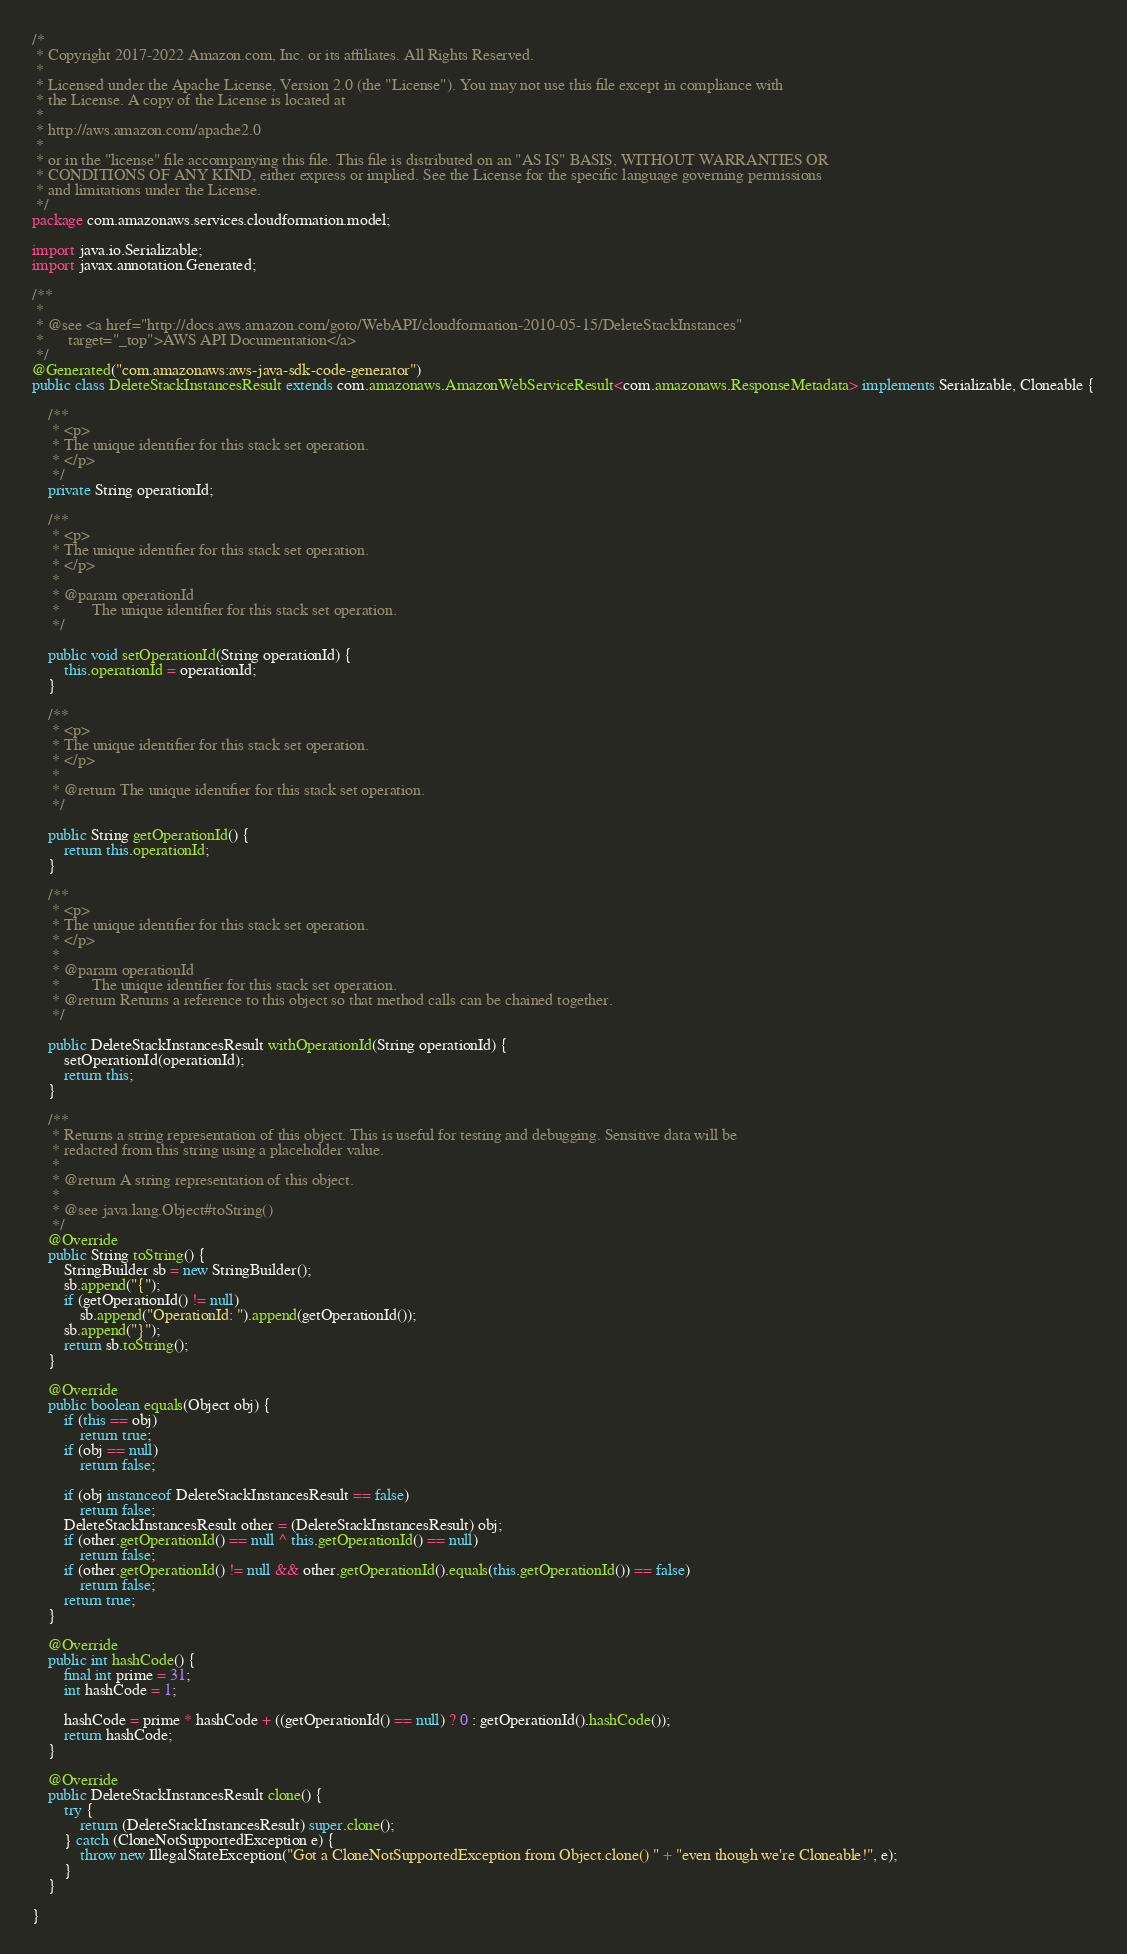<code> <loc_0><loc_0><loc_500><loc_500><_Java_>/*
 * Copyright 2017-2022 Amazon.com, Inc. or its affiliates. All Rights Reserved.
 * 
 * Licensed under the Apache License, Version 2.0 (the "License"). You may not use this file except in compliance with
 * the License. A copy of the License is located at
 * 
 * http://aws.amazon.com/apache2.0
 * 
 * or in the "license" file accompanying this file. This file is distributed on an "AS IS" BASIS, WITHOUT WARRANTIES OR
 * CONDITIONS OF ANY KIND, either express or implied. See the License for the specific language governing permissions
 * and limitations under the License.
 */
package com.amazonaws.services.cloudformation.model;

import java.io.Serializable;
import javax.annotation.Generated;

/**
 * 
 * @see <a href="http://docs.aws.amazon.com/goto/WebAPI/cloudformation-2010-05-15/DeleteStackInstances"
 *      target="_top">AWS API Documentation</a>
 */
@Generated("com.amazonaws:aws-java-sdk-code-generator")
public class DeleteStackInstancesResult extends com.amazonaws.AmazonWebServiceResult<com.amazonaws.ResponseMetadata> implements Serializable, Cloneable {

    /**
     * <p>
     * The unique identifier for this stack set operation.
     * </p>
     */
    private String operationId;

    /**
     * <p>
     * The unique identifier for this stack set operation.
     * </p>
     * 
     * @param operationId
     *        The unique identifier for this stack set operation.
     */

    public void setOperationId(String operationId) {
        this.operationId = operationId;
    }

    /**
     * <p>
     * The unique identifier for this stack set operation.
     * </p>
     * 
     * @return The unique identifier for this stack set operation.
     */

    public String getOperationId() {
        return this.operationId;
    }

    /**
     * <p>
     * The unique identifier for this stack set operation.
     * </p>
     * 
     * @param operationId
     *        The unique identifier for this stack set operation.
     * @return Returns a reference to this object so that method calls can be chained together.
     */

    public DeleteStackInstancesResult withOperationId(String operationId) {
        setOperationId(operationId);
        return this;
    }

    /**
     * Returns a string representation of this object. This is useful for testing and debugging. Sensitive data will be
     * redacted from this string using a placeholder value.
     *
     * @return A string representation of this object.
     *
     * @see java.lang.Object#toString()
     */
    @Override
    public String toString() {
        StringBuilder sb = new StringBuilder();
        sb.append("{");
        if (getOperationId() != null)
            sb.append("OperationId: ").append(getOperationId());
        sb.append("}");
        return sb.toString();
    }

    @Override
    public boolean equals(Object obj) {
        if (this == obj)
            return true;
        if (obj == null)
            return false;

        if (obj instanceof DeleteStackInstancesResult == false)
            return false;
        DeleteStackInstancesResult other = (DeleteStackInstancesResult) obj;
        if (other.getOperationId() == null ^ this.getOperationId() == null)
            return false;
        if (other.getOperationId() != null && other.getOperationId().equals(this.getOperationId()) == false)
            return false;
        return true;
    }

    @Override
    public int hashCode() {
        final int prime = 31;
        int hashCode = 1;

        hashCode = prime * hashCode + ((getOperationId() == null) ? 0 : getOperationId().hashCode());
        return hashCode;
    }

    @Override
    public DeleteStackInstancesResult clone() {
        try {
            return (DeleteStackInstancesResult) super.clone();
        } catch (CloneNotSupportedException e) {
            throw new IllegalStateException("Got a CloneNotSupportedException from Object.clone() " + "even though we're Cloneable!", e);
        }
    }

}
</code> 